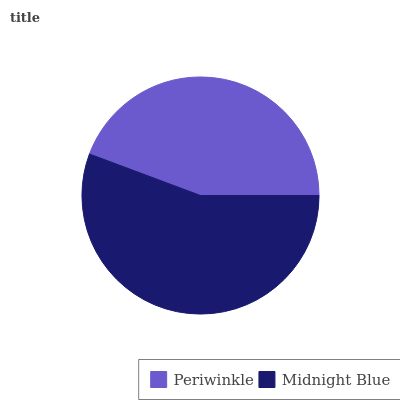Is Periwinkle the minimum?
Answer yes or no. Yes. Is Midnight Blue the maximum?
Answer yes or no. Yes. Is Midnight Blue the minimum?
Answer yes or no. No. Is Midnight Blue greater than Periwinkle?
Answer yes or no. Yes. Is Periwinkle less than Midnight Blue?
Answer yes or no. Yes. Is Periwinkle greater than Midnight Blue?
Answer yes or no. No. Is Midnight Blue less than Periwinkle?
Answer yes or no. No. Is Midnight Blue the high median?
Answer yes or no. Yes. Is Periwinkle the low median?
Answer yes or no. Yes. Is Periwinkle the high median?
Answer yes or no. No. Is Midnight Blue the low median?
Answer yes or no. No. 